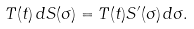Convert formula to latex. <formula><loc_0><loc_0><loc_500><loc_500>T ( t ) \, d S ( \sigma ) = T ( t ) S ^ { \prime } ( \sigma ) \, d \sigma .</formula> 